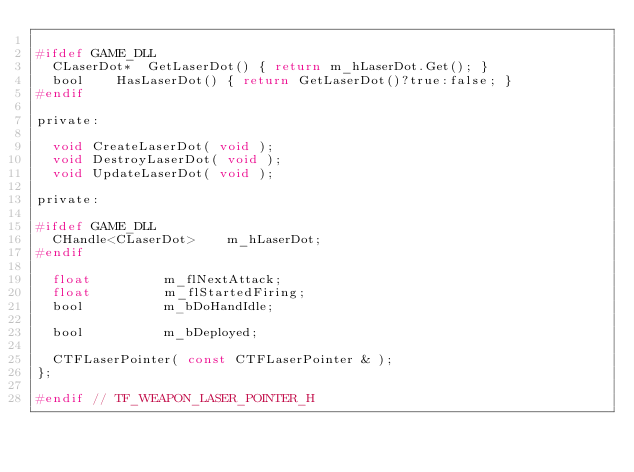<code> <loc_0><loc_0><loc_500><loc_500><_C_>
#ifdef GAME_DLL
	CLaserDot*	GetLaserDot() { return m_hLaserDot.Get(); }
	bool		HasLaserDot() { return GetLaserDot()?true:false; }
#endif

private:

	void CreateLaserDot( void );
	void DestroyLaserDot( void );
	void UpdateLaserDot( void );

private:

#ifdef GAME_DLL
	CHandle<CLaserDot>		m_hLaserDot;
#endif

	float					m_flNextAttack;
	float					m_flStartedFiring;
	bool					m_bDoHandIdle;

	bool					m_bDeployed;

	CTFLaserPointer( const CTFLaserPointer & );
};

#endif // TF_WEAPON_LASER_POINTER_H
</code> 